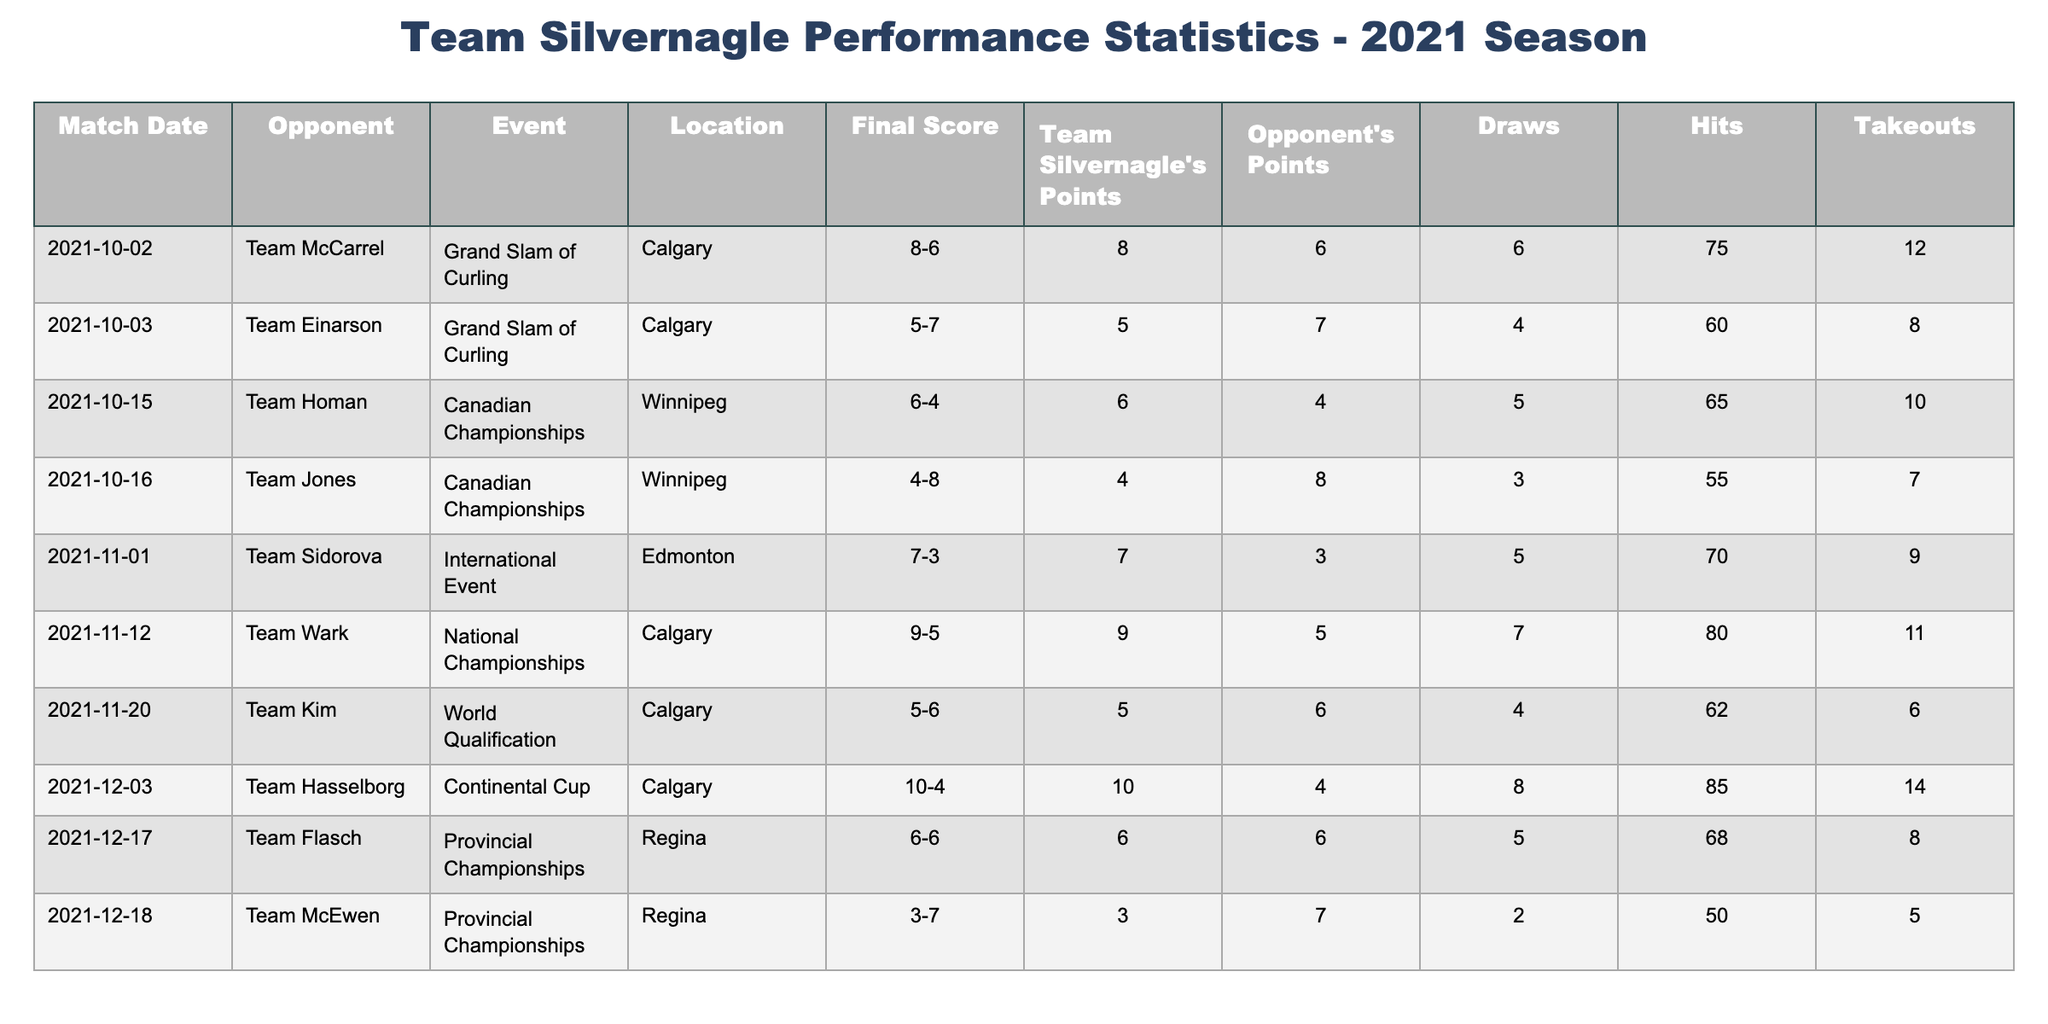What was Team Silvernagle's highest score in a single match during the 2021 season? By examining the "Team Silvernagle's Points" column, we identify that the highest score is 10, which occurred during the match against Team Hasselborg on December 3rd.
Answer: 10 What was the outcome of Team Silvernagle's match against Team Jones? Looking at the "Final Score" for the match against Team Jones, we see Silvernagle scored 4 points while Team Jones scored 8 points, indicating that Silvernagle lost the match.
Answer: Team Silvernagle lost How many times did Team Silvernagle score 6 points in the 2021 season? By filtering through the "Team Silvernagle's Points" column, we count the occurrences of the value 6, which appears three times in the matches against Team Flasch, Team Homan, and Team McCarrel.
Answer: 3 What is the average number of draws in Team Silvernagle's matches? To find the average, we sum the draws across all matches (6 + 4 + 5 + 3 + 5 + 7 + 4 + 8 + 5 + 2 = 49) and divide by the number of matches (10), resulting in an average of 4.9.
Answer: 4.9 Did Team Silvernagle ever score fewer points than their opponents? By checking the "Team Silvernagle's Points" against the "Opponent's Points," we find that Silvernagle scored fewer points in three matches: against Team Einarson, Team Jones, and Team McEwen.
Answer: Yes What was the total number of takeouts made by Team Silvernagle during the 2021 season? We add the takeouts from each match (12 + 8 + 10 + 7 + 9 + 11 + 6 + 14 + 8 + 5 = 88) to find that Team Silvernagle made a total of 88 takeouts in the season.
Answer: 88 Which event did Team Silvernagle perform best in based on their points? By comparing the scores in different events, Team Silvernagle’s best performance came during the Continental Cup against Team Hasselborg where they scored 10 points, the highest in any event.
Answer: Continental Cup How many matches did Team Silvernagle play in locations outside of Calgary? By reviewing the "Location" column, we find that they played in Winnipeg and Regina for a total of 3 matches, indicating they played 3 matches outside of Calgary.
Answer: 3 What was the point difference in the match against Team Flasch? The point difference can be calculated by subtracting the scores: 6 (Silvernagle) - 6 (Flasch) results in a point difference of 0, indicating a tie.
Answer: 0 How did Team Silvernagle's performance change from the match against Team McCarrel to the match against Team Einarson? In the match against Team McCarrel, Silvernagle scored 8 points, and against Team Einarson, they scored only 5 points, showing a decrease of 3 points between these two matches.
Answer: Decreased by 3 points Which match had the highest number of hits recorded by Team Silvernagle? The match against Team Hasselborg had the highest recorded hits, with a total of 85, which is the highest in the "Hits" column across all matches.
Answer: 85 hits 